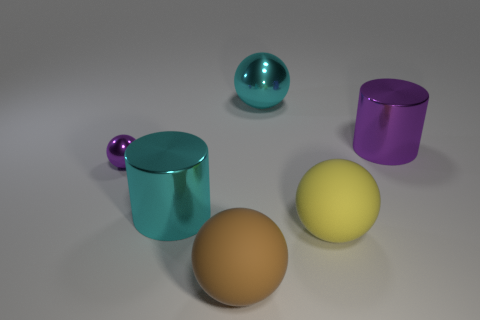Are there any other things that are the same size as the purple sphere?
Your answer should be very brief. No. There is another ball that is made of the same material as the brown ball; what color is it?
Your response must be concise. Yellow. What number of other things have the same material as the brown thing?
Your response must be concise. 1. Is the size of the matte thing on the right side of the brown matte thing the same as the tiny purple thing?
Your answer should be compact. No. What is the color of the other cylinder that is the same size as the cyan cylinder?
Provide a short and direct response. Purple. How many big yellow things are left of the tiny purple metallic thing?
Provide a short and direct response. 0. Are any large gray metal things visible?
Ensure brevity in your answer.  No. There is a metallic ball left of the metallic ball that is to the right of the large cyan metal thing that is in front of the large purple metallic object; what size is it?
Keep it short and to the point. Small. How many other objects are the same size as the purple ball?
Provide a succinct answer. 0. There is a cylinder behind the big cyan shiny cylinder; how big is it?
Offer a very short reply. Large. 